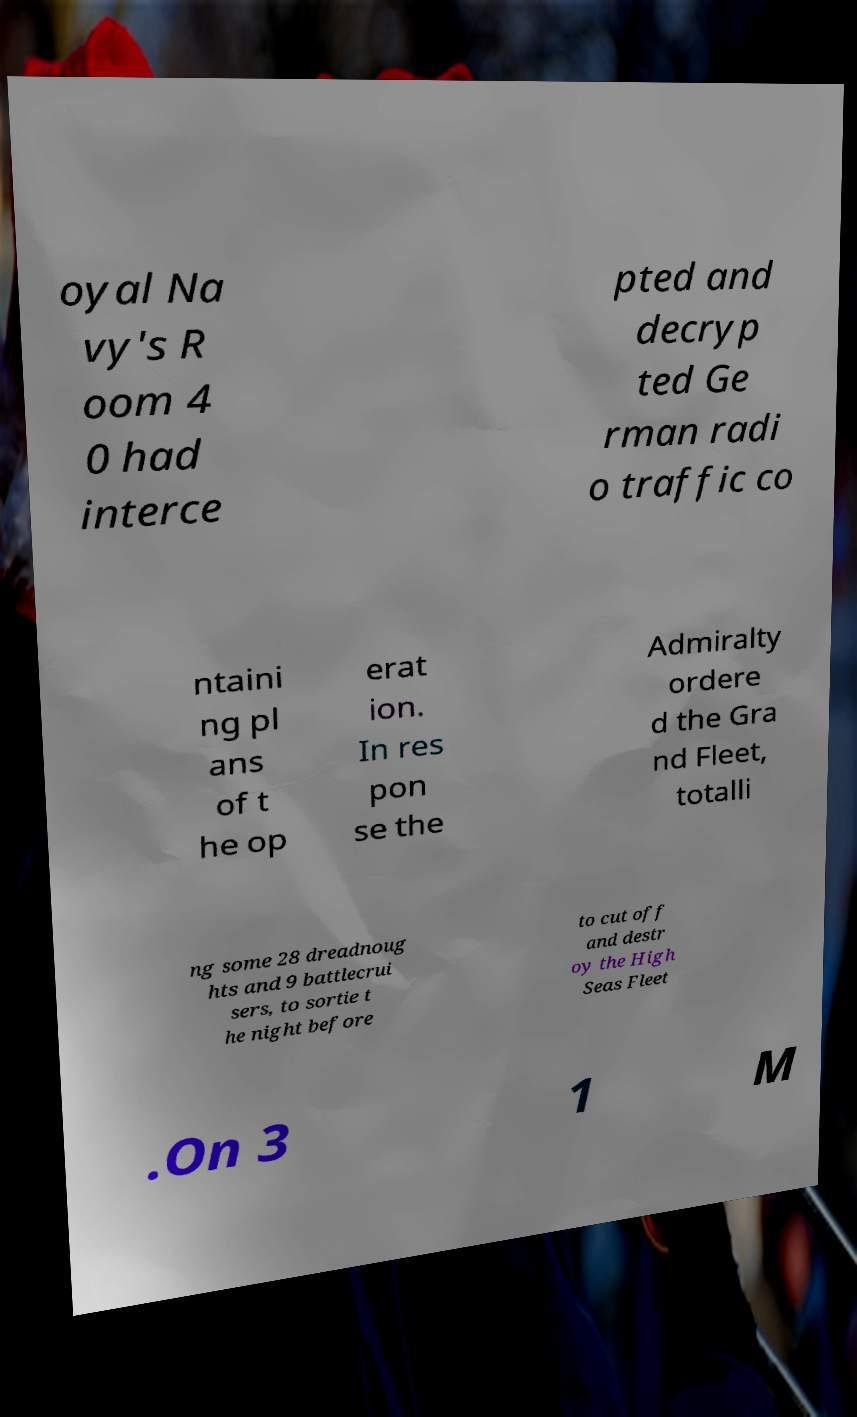Can you accurately transcribe the text from the provided image for me? oyal Na vy's R oom 4 0 had interce pted and decryp ted Ge rman radi o traffic co ntaini ng pl ans of t he op erat ion. In res pon se the Admiralty ordere d the Gra nd Fleet, totalli ng some 28 dreadnoug hts and 9 battlecrui sers, to sortie t he night before to cut off and destr oy the High Seas Fleet .On 3 1 M 